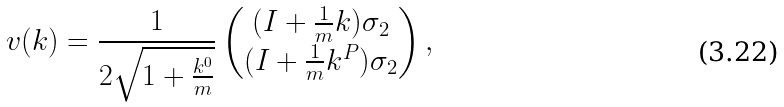Convert formula to latex. <formula><loc_0><loc_0><loc_500><loc_500>v ( k ) = \frac { 1 } { 2 \sqrt { 1 + \frac { k ^ { 0 } } { m } } } \begin{pmatrix} ( I + \frac { 1 } { m } { k } ) \sigma _ { 2 } \\ ( I + \frac { 1 } { m } { k } ^ { P } ) \sigma _ { 2 } \end{pmatrix} ,</formula> 